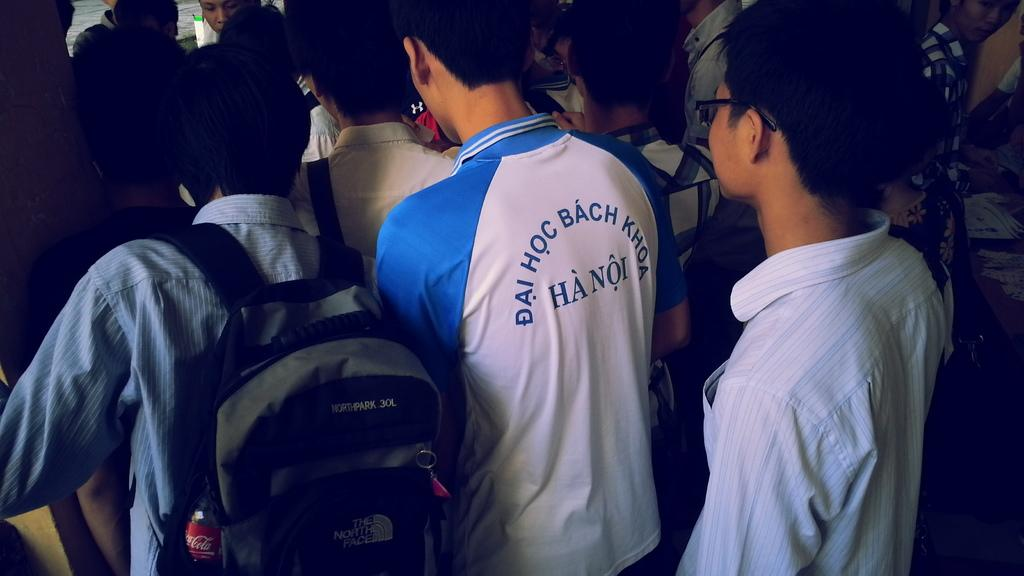<image>
Give a short and clear explanation of the subsequent image. The city these players are from is Hanoi city 